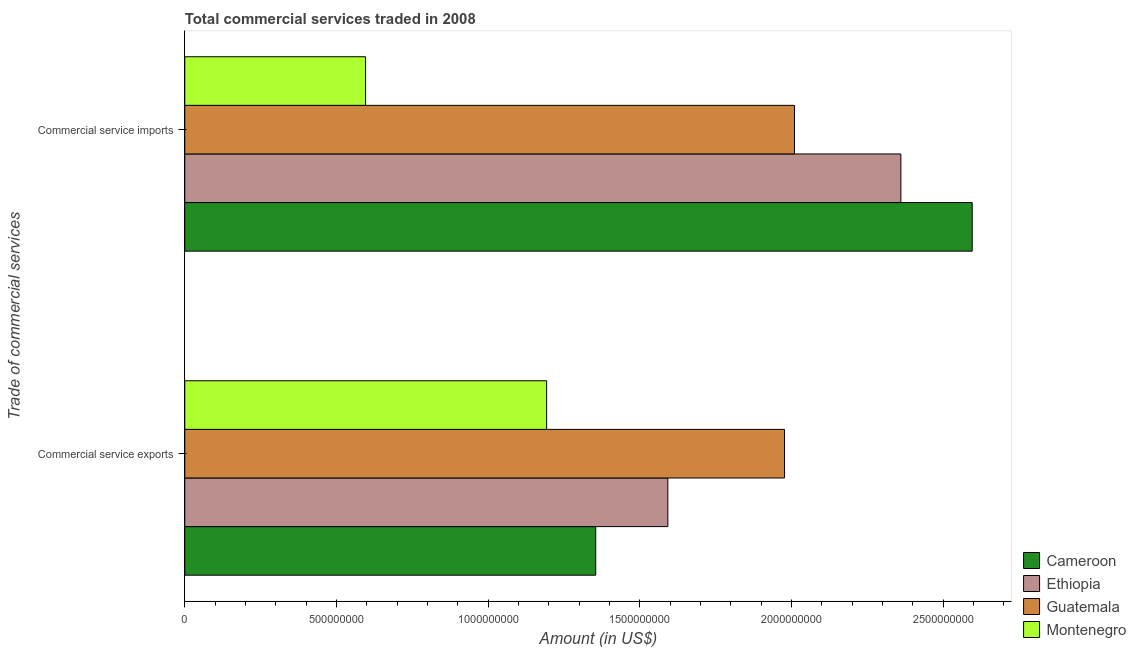How many different coloured bars are there?
Your answer should be very brief. 4. Are the number of bars on each tick of the Y-axis equal?
Provide a succinct answer. Yes. How many bars are there on the 2nd tick from the top?
Give a very brief answer. 4. How many bars are there on the 1st tick from the bottom?
Provide a short and direct response. 4. What is the label of the 1st group of bars from the top?
Offer a very short reply. Commercial service imports. What is the amount of commercial service imports in Ethiopia?
Keep it short and to the point. 2.36e+09. Across all countries, what is the maximum amount of commercial service imports?
Make the answer very short. 2.60e+09. Across all countries, what is the minimum amount of commercial service exports?
Give a very brief answer. 1.19e+09. In which country was the amount of commercial service imports maximum?
Your answer should be compact. Cameroon. In which country was the amount of commercial service imports minimum?
Provide a succinct answer. Montenegro. What is the total amount of commercial service imports in the graph?
Give a very brief answer. 7.56e+09. What is the difference between the amount of commercial service imports in Montenegro and that in Guatemala?
Your response must be concise. -1.41e+09. What is the difference between the amount of commercial service exports in Montenegro and the amount of commercial service imports in Guatemala?
Keep it short and to the point. -8.17e+08. What is the average amount of commercial service imports per country?
Your response must be concise. 1.89e+09. What is the difference between the amount of commercial service exports and amount of commercial service imports in Montenegro?
Your answer should be compact. 5.97e+08. In how many countries, is the amount of commercial service exports greater than 1800000000 US$?
Provide a succinct answer. 1. What is the ratio of the amount of commercial service exports in Ethiopia to that in Montenegro?
Your answer should be very brief. 1.34. Is the amount of commercial service exports in Montenegro less than that in Ethiopia?
Offer a very short reply. Yes. In how many countries, is the amount of commercial service exports greater than the average amount of commercial service exports taken over all countries?
Your response must be concise. 2. What does the 1st bar from the top in Commercial service imports represents?
Offer a very short reply. Montenegro. What does the 1st bar from the bottom in Commercial service exports represents?
Give a very brief answer. Cameroon. How many bars are there?
Keep it short and to the point. 8. What is the difference between two consecutive major ticks on the X-axis?
Provide a succinct answer. 5.00e+08. Are the values on the major ticks of X-axis written in scientific E-notation?
Offer a terse response. No. Does the graph contain any zero values?
Ensure brevity in your answer.  No. Does the graph contain grids?
Offer a terse response. No. Where does the legend appear in the graph?
Offer a very short reply. Bottom right. How many legend labels are there?
Keep it short and to the point. 4. What is the title of the graph?
Ensure brevity in your answer.  Total commercial services traded in 2008. What is the label or title of the X-axis?
Offer a terse response. Amount (in US$). What is the label or title of the Y-axis?
Make the answer very short. Trade of commercial services. What is the Amount (in US$) of Cameroon in Commercial service exports?
Your answer should be very brief. 1.35e+09. What is the Amount (in US$) of Ethiopia in Commercial service exports?
Your answer should be very brief. 1.59e+09. What is the Amount (in US$) of Guatemala in Commercial service exports?
Keep it short and to the point. 1.98e+09. What is the Amount (in US$) in Montenegro in Commercial service exports?
Provide a succinct answer. 1.19e+09. What is the Amount (in US$) of Cameroon in Commercial service imports?
Your response must be concise. 2.60e+09. What is the Amount (in US$) of Ethiopia in Commercial service imports?
Ensure brevity in your answer.  2.36e+09. What is the Amount (in US$) of Guatemala in Commercial service imports?
Give a very brief answer. 2.01e+09. What is the Amount (in US$) of Montenegro in Commercial service imports?
Provide a succinct answer. 5.96e+08. Across all Trade of commercial services, what is the maximum Amount (in US$) in Cameroon?
Your answer should be very brief. 2.60e+09. Across all Trade of commercial services, what is the maximum Amount (in US$) in Ethiopia?
Provide a succinct answer. 2.36e+09. Across all Trade of commercial services, what is the maximum Amount (in US$) in Guatemala?
Offer a terse response. 2.01e+09. Across all Trade of commercial services, what is the maximum Amount (in US$) of Montenegro?
Provide a succinct answer. 1.19e+09. Across all Trade of commercial services, what is the minimum Amount (in US$) of Cameroon?
Offer a terse response. 1.35e+09. Across all Trade of commercial services, what is the minimum Amount (in US$) in Ethiopia?
Your answer should be compact. 1.59e+09. Across all Trade of commercial services, what is the minimum Amount (in US$) of Guatemala?
Make the answer very short. 1.98e+09. Across all Trade of commercial services, what is the minimum Amount (in US$) in Montenegro?
Give a very brief answer. 5.96e+08. What is the total Amount (in US$) of Cameroon in the graph?
Make the answer very short. 3.95e+09. What is the total Amount (in US$) in Ethiopia in the graph?
Ensure brevity in your answer.  3.95e+09. What is the total Amount (in US$) in Guatemala in the graph?
Your answer should be very brief. 3.99e+09. What is the total Amount (in US$) in Montenegro in the graph?
Ensure brevity in your answer.  1.79e+09. What is the difference between the Amount (in US$) of Cameroon in Commercial service exports and that in Commercial service imports?
Provide a short and direct response. -1.24e+09. What is the difference between the Amount (in US$) of Ethiopia in Commercial service exports and that in Commercial service imports?
Give a very brief answer. -7.68e+08. What is the difference between the Amount (in US$) of Guatemala in Commercial service exports and that in Commercial service imports?
Offer a very short reply. -3.29e+07. What is the difference between the Amount (in US$) in Montenegro in Commercial service exports and that in Commercial service imports?
Offer a very short reply. 5.97e+08. What is the difference between the Amount (in US$) of Cameroon in Commercial service exports and the Amount (in US$) of Ethiopia in Commercial service imports?
Ensure brevity in your answer.  -1.01e+09. What is the difference between the Amount (in US$) of Cameroon in Commercial service exports and the Amount (in US$) of Guatemala in Commercial service imports?
Your response must be concise. -6.55e+08. What is the difference between the Amount (in US$) in Cameroon in Commercial service exports and the Amount (in US$) in Montenegro in Commercial service imports?
Provide a short and direct response. 7.59e+08. What is the difference between the Amount (in US$) in Ethiopia in Commercial service exports and the Amount (in US$) in Guatemala in Commercial service imports?
Keep it short and to the point. -4.18e+08. What is the difference between the Amount (in US$) of Ethiopia in Commercial service exports and the Amount (in US$) of Montenegro in Commercial service imports?
Offer a very short reply. 9.97e+08. What is the difference between the Amount (in US$) in Guatemala in Commercial service exports and the Amount (in US$) in Montenegro in Commercial service imports?
Make the answer very short. 1.38e+09. What is the average Amount (in US$) in Cameroon per Trade of commercial services?
Ensure brevity in your answer.  1.98e+09. What is the average Amount (in US$) in Ethiopia per Trade of commercial services?
Provide a short and direct response. 1.98e+09. What is the average Amount (in US$) of Guatemala per Trade of commercial services?
Your response must be concise. 1.99e+09. What is the average Amount (in US$) in Montenegro per Trade of commercial services?
Provide a short and direct response. 8.94e+08. What is the difference between the Amount (in US$) in Cameroon and Amount (in US$) in Ethiopia in Commercial service exports?
Give a very brief answer. -2.38e+08. What is the difference between the Amount (in US$) of Cameroon and Amount (in US$) of Guatemala in Commercial service exports?
Ensure brevity in your answer.  -6.22e+08. What is the difference between the Amount (in US$) of Cameroon and Amount (in US$) of Montenegro in Commercial service exports?
Provide a succinct answer. 1.62e+08. What is the difference between the Amount (in US$) of Ethiopia and Amount (in US$) of Guatemala in Commercial service exports?
Your response must be concise. -3.85e+08. What is the difference between the Amount (in US$) of Ethiopia and Amount (in US$) of Montenegro in Commercial service exports?
Your answer should be compact. 4.00e+08. What is the difference between the Amount (in US$) in Guatemala and Amount (in US$) in Montenegro in Commercial service exports?
Your answer should be compact. 7.84e+08. What is the difference between the Amount (in US$) in Cameroon and Amount (in US$) in Ethiopia in Commercial service imports?
Offer a very short reply. 2.35e+08. What is the difference between the Amount (in US$) in Cameroon and Amount (in US$) in Guatemala in Commercial service imports?
Ensure brevity in your answer.  5.86e+08. What is the difference between the Amount (in US$) of Cameroon and Amount (in US$) of Montenegro in Commercial service imports?
Your answer should be compact. 2.00e+09. What is the difference between the Amount (in US$) in Ethiopia and Amount (in US$) in Guatemala in Commercial service imports?
Provide a short and direct response. 3.51e+08. What is the difference between the Amount (in US$) of Ethiopia and Amount (in US$) of Montenegro in Commercial service imports?
Keep it short and to the point. 1.76e+09. What is the difference between the Amount (in US$) in Guatemala and Amount (in US$) in Montenegro in Commercial service imports?
Give a very brief answer. 1.41e+09. What is the ratio of the Amount (in US$) of Cameroon in Commercial service exports to that in Commercial service imports?
Provide a short and direct response. 0.52. What is the ratio of the Amount (in US$) in Ethiopia in Commercial service exports to that in Commercial service imports?
Offer a very short reply. 0.67. What is the ratio of the Amount (in US$) in Guatemala in Commercial service exports to that in Commercial service imports?
Ensure brevity in your answer.  0.98. What is the ratio of the Amount (in US$) of Montenegro in Commercial service exports to that in Commercial service imports?
Offer a very short reply. 2. What is the difference between the highest and the second highest Amount (in US$) of Cameroon?
Provide a short and direct response. 1.24e+09. What is the difference between the highest and the second highest Amount (in US$) in Ethiopia?
Keep it short and to the point. 7.68e+08. What is the difference between the highest and the second highest Amount (in US$) in Guatemala?
Make the answer very short. 3.29e+07. What is the difference between the highest and the second highest Amount (in US$) of Montenegro?
Your response must be concise. 5.97e+08. What is the difference between the highest and the lowest Amount (in US$) of Cameroon?
Your response must be concise. 1.24e+09. What is the difference between the highest and the lowest Amount (in US$) of Ethiopia?
Provide a short and direct response. 7.68e+08. What is the difference between the highest and the lowest Amount (in US$) in Guatemala?
Offer a terse response. 3.29e+07. What is the difference between the highest and the lowest Amount (in US$) of Montenegro?
Ensure brevity in your answer.  5.97e+08. 